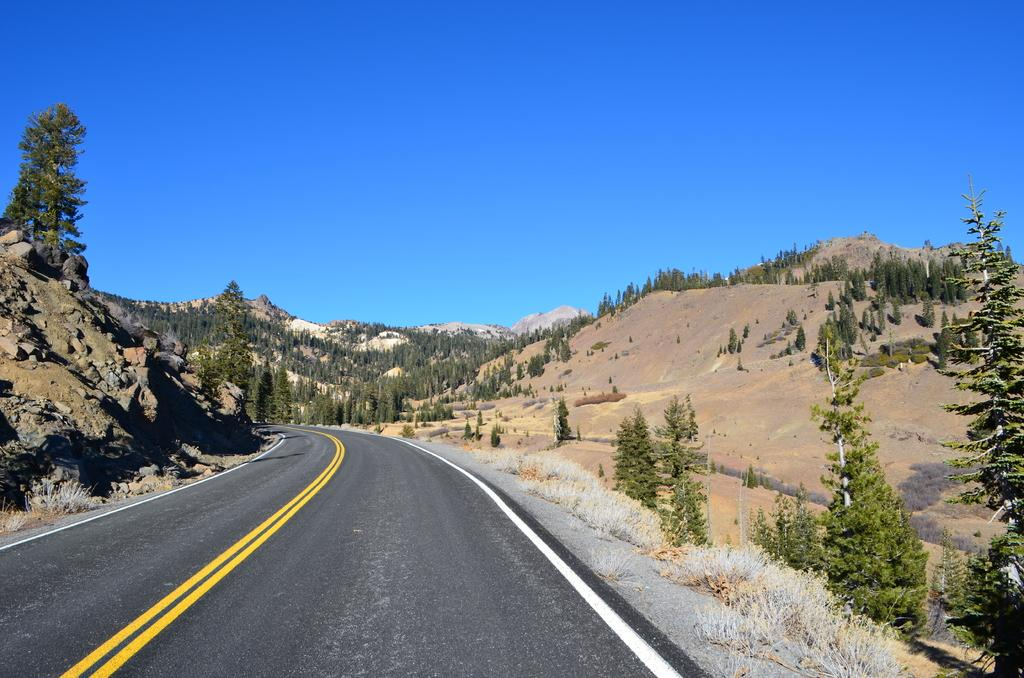What type of pathway is visible in the image? There is a road in the image. What natural elements can be seen in the image? There are trees and mountains in the image. What type of vegetation is present in the image? There are plants in the image. What is visible in the background of the image? The sky is visible in the image. What type of metal is used to construct the ants in the image? There are no ants present in the image, and therefore no metal construction can be observed. 